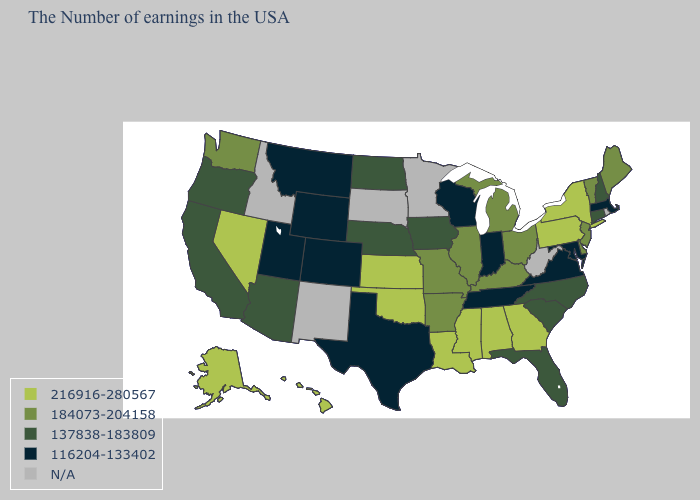What is the value of Vermont?
Be succinct. 184073-204158. Does Tennessee have the highest value in the USA?
Answer briefly. No. Among the states that border Connecticut , which have the lowest value?
Be succinct. Massachusetts. Does the map have missing data?
Quick response, please. Yes. What is the value of Kansas?
Short answer required. 216916-280567. Name the states that have a value in the range 216916-280567?
Give a very brief answer. New York, Pennsylvania, Georgia, Alabama, Mississippi, Louisiana, Kansas, Oklahoma, Nevada, Alaska, Hawaii. Is the legend a continuous bar?
Answer briefly. No. What is the value of Washington?
Short answer required. 184073-204158. Name the states that have a value in the range 137838-183809?
Quick response, please. New Hampshire, Connecticut, North Carolina, South Carolina, Florida, Iowa, Nebraska, North Dakota, Arizona, California, Oregon. Does Mississippi have the lowest value in the South?
Be succinct. No. What is the value of Louisiana?
Short answer required. 216916-280567. Name the states that have a value in the range 116204-133402?
Be succinct. Massachusetts, Maryland, Virginia, Indiana, Tennessee, Wisconsin, Texas, Wyoming, Colorado, Utah, Montana. What is the lowest value in states that border Oklahoma?
Be succinct. 116204-133402. Does the first symbol in the legend represent the smallest category?
Write a very short answer. No. 